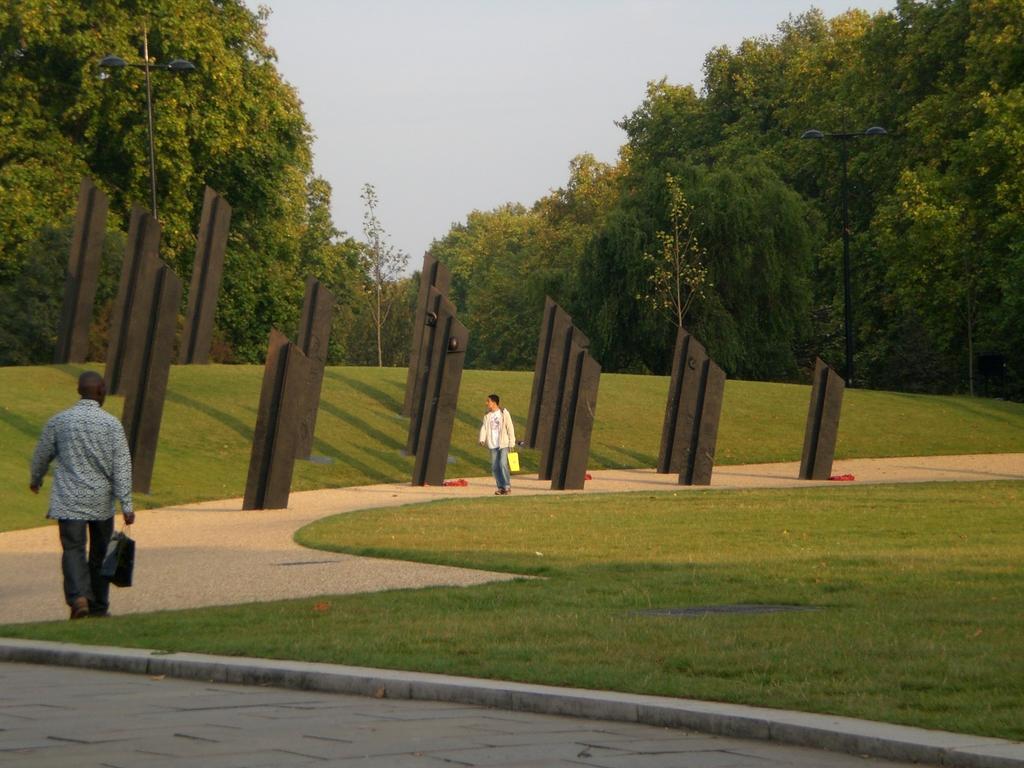Please provide a concise description of this image. In this image, we can see two men are some objects. Here we can see few objects are visible in the image. Here we can see walkways, grass, red color objects and poles. Background we can see trees and sky. 